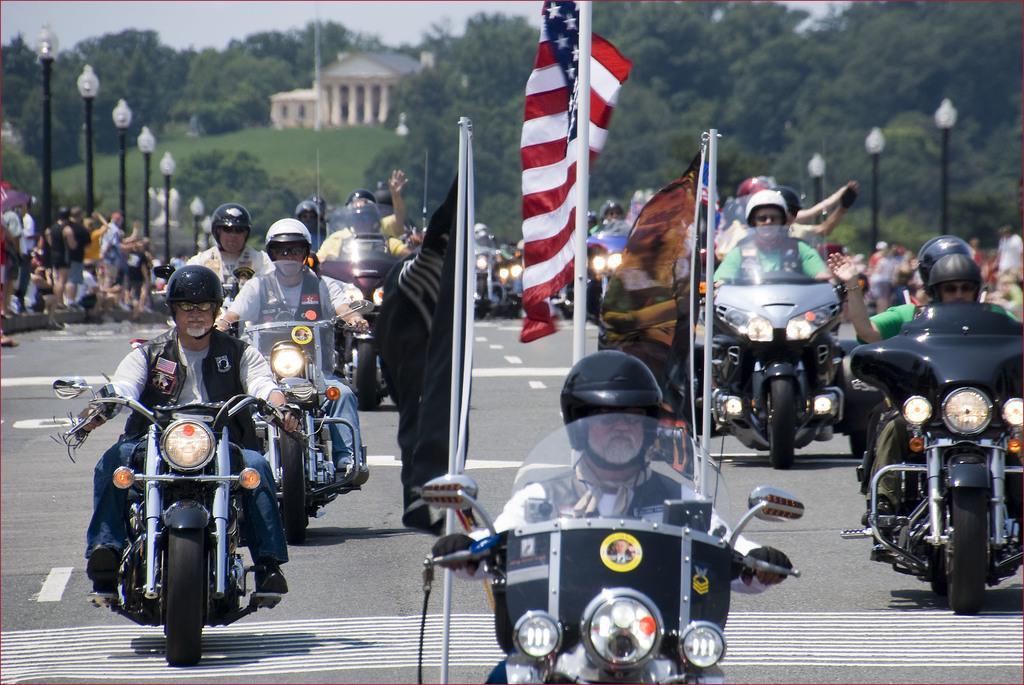Describe this image in one or two sentences. In this image, we can see some persons wearing clothes and riding bikes. There are some persons standing beside poles. There is a flag in the middle of the image. In the background of the image, there is a building and some trees. 